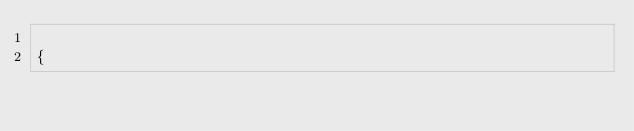Convert code to text. <code><loc_0><loc_0><loc_500><loc_500><_Awk_>
{</code> 